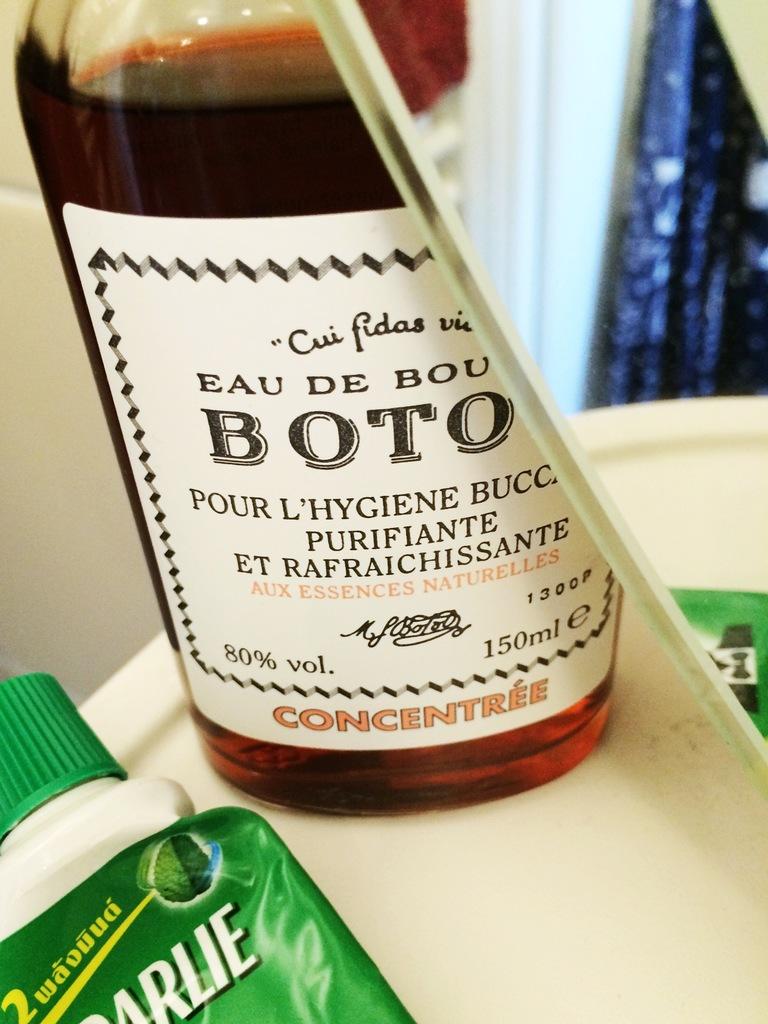What is the drink name?
Make the answer very short. Boto. What is the alcohol percentage per volume?
Keep it short and to the point. 80. 